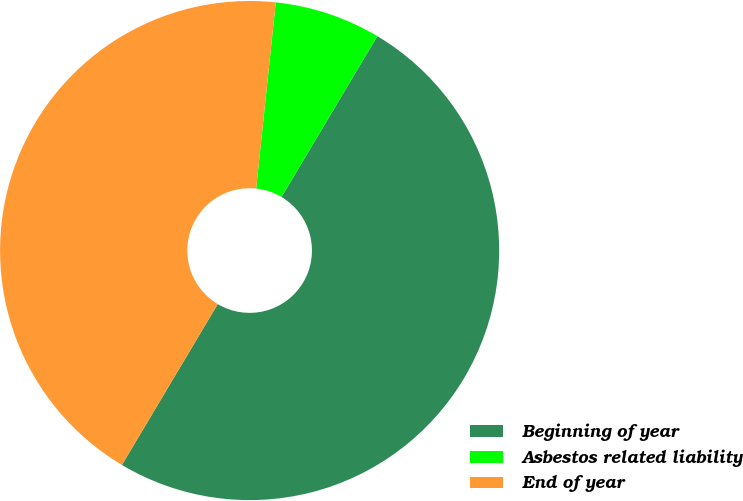Convert chart. <chart><loc_0><loc_0><loc_500><loc_500><pie_chart><fcel>Beginning of year<fcel>Asbestos related liability<fcel>End of year<nl><fcel>50.0%<fcel>6.88%<fcel>43.12%<nl></chart> 